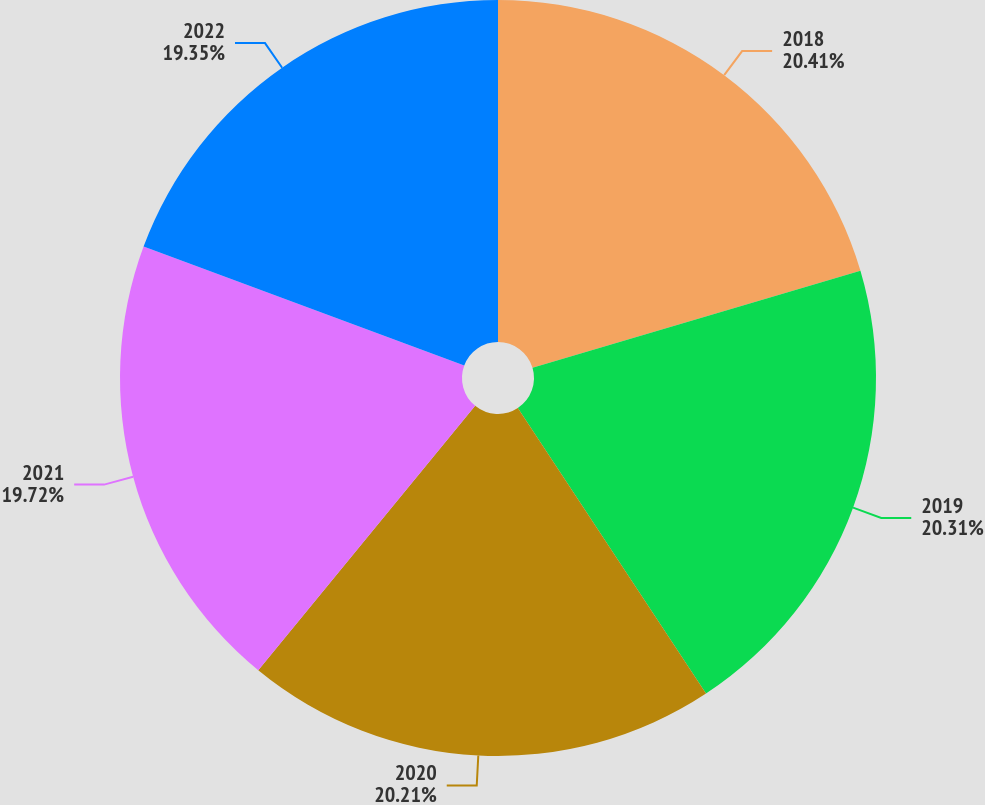<chart> <loc_0><loc_0><loc_500><loc_500><pie_chart><fcel>2018<fcel>2019<fcel>2020<fcel>2021<fcel>2022<nl><fcel>20.42%<fcel>20.31%<fcel>20.21%<fcel>19.72%<fcel>19.35%<nl></chart> 